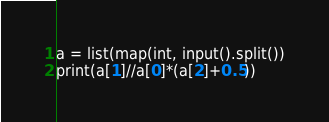Convert code to text. <code><loc_0><loc_0><loc_500><loc_500><_Python_>a = list(map(int, input().split())
print(a[1]//a[0]*(a[2]+0.5))</code> 